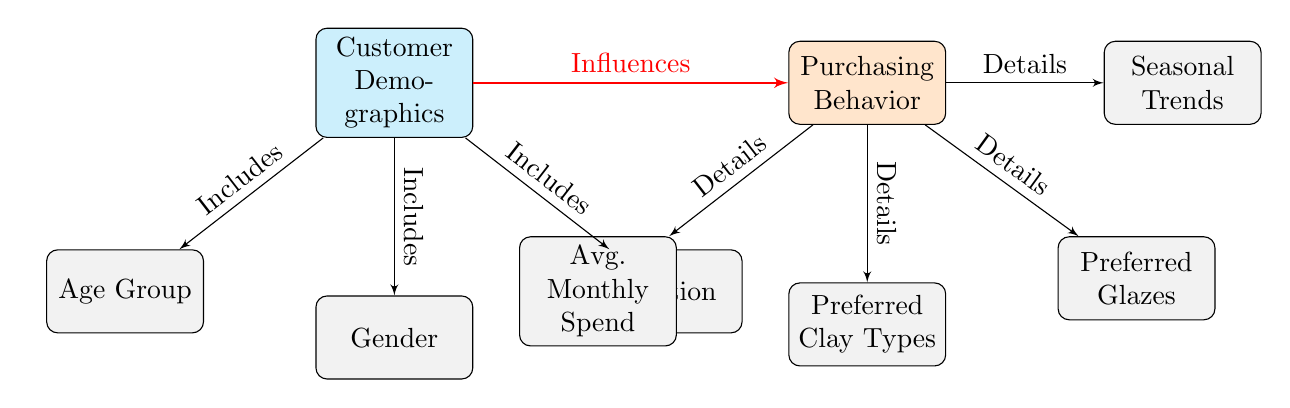What are the three components included in Customer Demographics? The diagram shows that Customer Demographics includes Age Group, Gender, and Location as its components.
Answer: Age Group, Gender, Location How many Purchasing Behavior components are there? By counting the blocks listed under Purchasing Behavior, we find that there are four, which are Avg. Monthly Spend, Preferred Clay Types, Preferred Glazes, and Seasonal Trends.
Answer: Four What relationship does demographics have with purchasing behavior? The diagram depicts a directed line from Customer Demographics to Purchasing Behavior with the label "Influences," indicating that demographics significantly affect purchasing behavior patterns.
Answer: Influences Which component is associated with Avg. Monthly Spend? Avg. Monthly Spend is a sub-component under Purchasing Behavior, indicated by the line labeled "Details" that originates from Purchasing Behavior.
Answer: Purchasing Behavior What flows from Purchasing Behavior to the Seasonal Trends component? The diagram shows that Purchasing Behavior also has a flow to Seasonal Trends with a label of "Details," demonstrating a connection between behavior and trends.
Answer: Details Which component directly influences Preferred Clay Types? The component Preferred Clay Types falls under Purchasing Behavior, which is influenced by Customer Demographics, positioning Preferred Clay Types as a result of those demographics.
Answer: Purchasing Behavior How does Gender relate to Customer Demographics? The diagram directly indicates that Gender is one of the components included in Customer Demographics, signifying its importance in demographic analysis.
Answer: Included What are the details considered within Purchasing Behavior? The diagram reveals that the details considered within Purchasing Behavior consist of Avg. Monthly Spend, Preferred Clay Types, Preferred Glazes, and Seasonal Trends allowing for a breakdown of purchasing characteristics.
Answer: Avg. Monthly Spend, Preferred Clay Types, Preferred Glazes, Seasonal Trends 